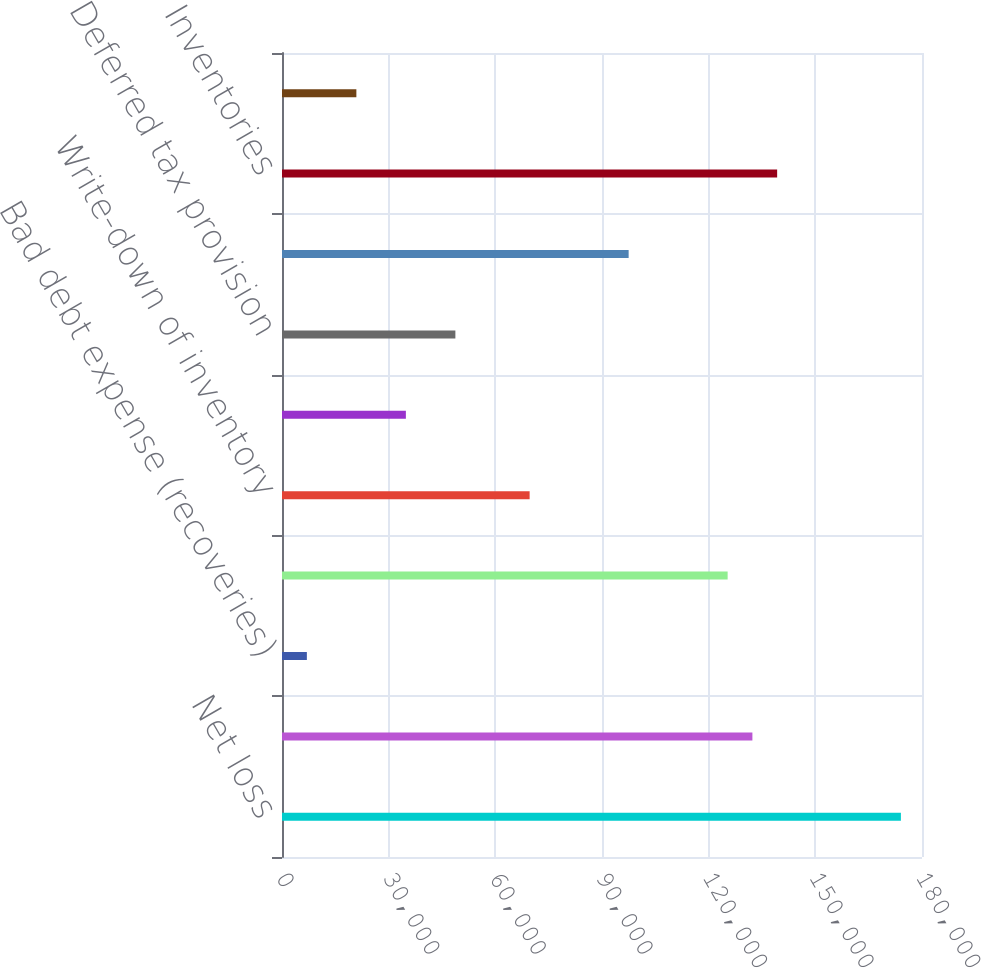Convert chart to OTSL. <chart><loc_0><loc_0><loc_500><loc_500><bar_chart><fcel>Net loss<fcel>Depreciation and amortization<fcel>Bad debt expense (recoveries)<fcel>Stock-based compensation<fcel>Write-down of inventory<fcel>Loss on disposal of fixed<fcel>Deferred tax provision<fcel>Accounts receivable<fcel>Inventories<fcel>Prepaid expenses and other<nl><fcel>174067<fcel>132299<fcel>6993.4<fcel>125337<fcel>69646<fcel>34839<fcel>48761.8<fcel>97491.6<fcel>139260<fcel>20916.2<nl></chart> 